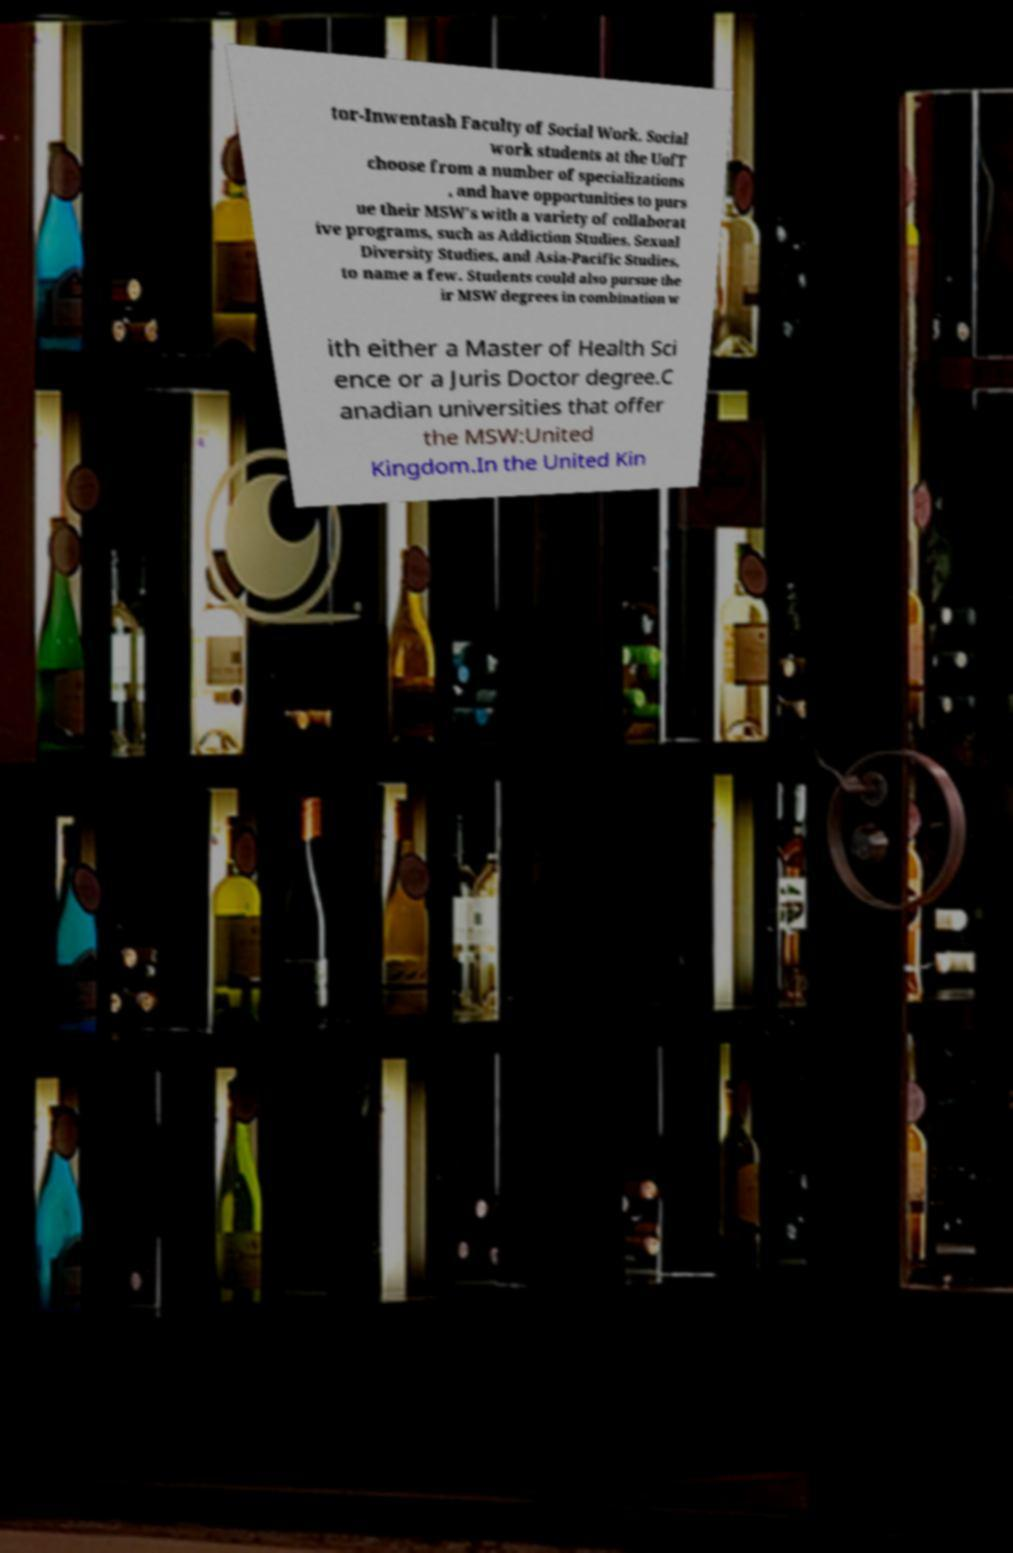Could you extract and type out the text from this image? tor-Inwentash Faculty of Social Work. Social work students at the UofT choose from a number of specializations , and have opportunities to purs ue their MSW's with a variety of collaborat ive programs, such as Addiction Studies, Sexual Diversity Studies, and Asia-Pacific Studies, to name a few. Students could also pursue the ir MSW degrees in combination w ith either a Master of Health Sci ence or a Juris Doctor degree.C anadian universities that offer the MSW:United Kingdom.In the United Kin 